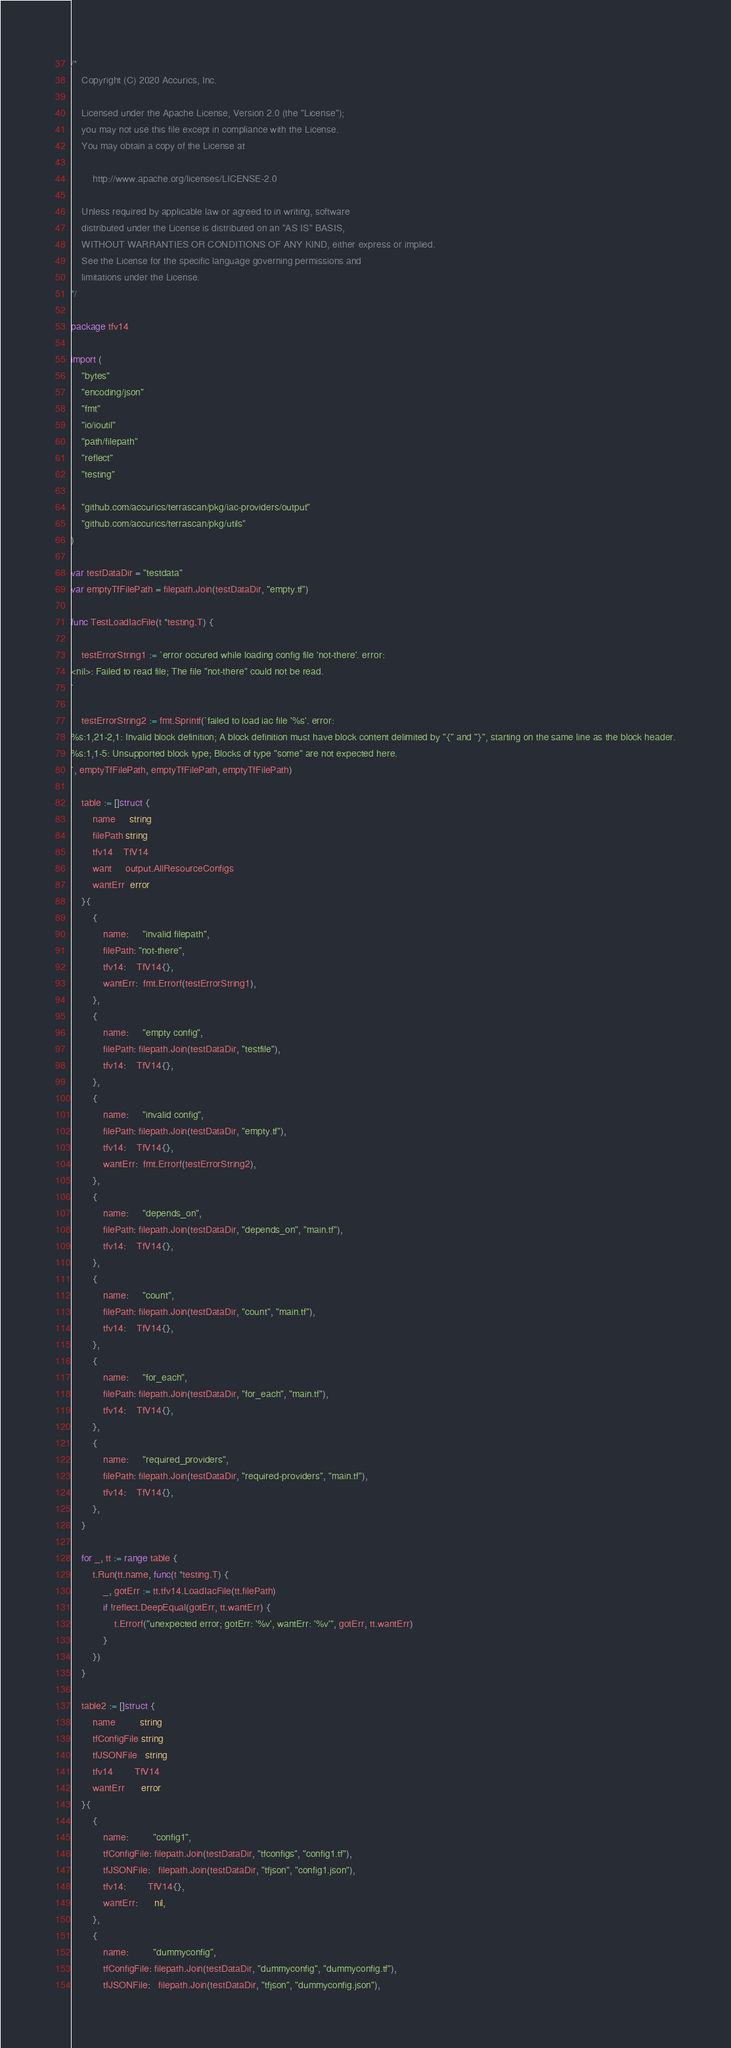<code> <loc_0><loc_0><loc_500><loc_500><_Go_>/*
    Copyright (C) 2020 Accurics, Inc.

	Licensed under the Apache License, Version 2.0 (the "License");
    you may not use this file except in compliance with the License.
    You may obtain a copy of the License at

		http://www.apache.org/licenses/LICENSE-2.0

	Unless required by applicable law or agreed to in writing, software
    distributed under the License is distributed on an "AS IS" BASIS,
    WITHOUT WARRANTIES OR CONDITIONS OF ANY KIND, either express or implied.
    See the License for the specific language governing permissions and
    limitations under the License.
*/

package tfv14

import (
	"bytes"
	"encoding/json"
	"fmt"
	"io/ioutil"
	"path/filepath"
	"reflect"
	"testing"

	"github.com/accurics/terrascan/pkg/iac-providers/output"
	"github.com/accurics/terrascan/pkg/utils"
)

var testDataDir = "testdata"
var emptyTfFilePath = filepath.Join(testDataDir, "empty.tf")

func TestLoadIacFile(t *testing.T) {

	testErrorString1 := `error occured while loading config file 'not-there'. error:
<nil>: Failed to read file; The file "not-there" could not be read.
`

	testErrorString2 := fmt.Sprintf(`failed to load iac file '%s'. error:
%s:1,21-2,1: Invalid block definition; A block definition must have block content delimited by "{" and "}", starting on the same line as the block header.
%s:1,1-5: Unsupported block type; Blocks of type "some" are not expected here.
`, emptyTfFilePath, emptyTfFilePath, emptyTfFilePath)

	table := []struct {
		name     string
		filePath string
		tfv14    TfV14
		want     output.AllResourceConfigs
		wantErr  error
	}{
		{
			name:     "invalid filepath",
			filePath: "not-there",
			tfv14:    TfV14{},
			wantErr:  fmt.Errorf(testErrorString1),
		},
		{
			name:     "empty config",
			filePath: filepath.Join(testDataDir, "testfile"),
			tfv14:    TfV14{},
		},
		{
			name:     "invalid config",
			filePath: filepath.Join(testDataDir, "empty.tf"),
			tfv14:    TfV14{},
			wantErr:  fmt.Errorf(testErrorString2),
		},
		{
			name:     "depends_on",
			filePath: filepath.Join(testDataDir, "depends_on", "main.tf"),
			tfv14:    TfV14{},
		},
		{
			name:     "count",
			filePath: filepath.Join(testDataDir, "count", "main.tf"),
			tfv14:    TfV14{},
		},
		{
			name:     "for_each",
			filePath: filepath.Join(testDataDir, "for_each", "main.tf"),
			tfv14:    TfV14{},
		},
		{
			name:     "required_providers",
			filePath: filepath.Join(testDataDir, "required-providers", "main.tf"),
			tfv14:    TfV14{},
		},
	}

	for _, tt := range table {
		t.Run(tt.name, func(t *testing.T) {
			_, gotErr := tt.tfv14.LoadIacFile(tt.filePath)
			if !reflect.DeepEqual(gotErr, tt.wantErr) {
				t.Errorf("unexpected error; gotErr: '%v', wantErr: '%v'", gotErr, tt.wantErr)
			}
		})
	}

	table2 := []struct {
		name         string
		tfConfigFile string
		tfJSONFile   string
		tfv14        TfV14
		wantErr      error
	}{
		{
			name:         "config1",
			tfConfigFile: filepath.Join(testDataDir, "tfconfigs", "config1.tf"),
			tfJSONFile:   filepath.Join(testDataDir, "tfjson", "config1.json"),
			tfv14:        TfV14{},
			wantErr:      nil,
		},
		{
			name:         "dummyconfig",
			tfConfigFile: filepath.Join(testDataDir, "dummyconfig", "dummyconfig.tf"),
			tfJSONFile:   filepath.Join(testDataDir, "tfjson", "dummyconfig.json"),</code> 